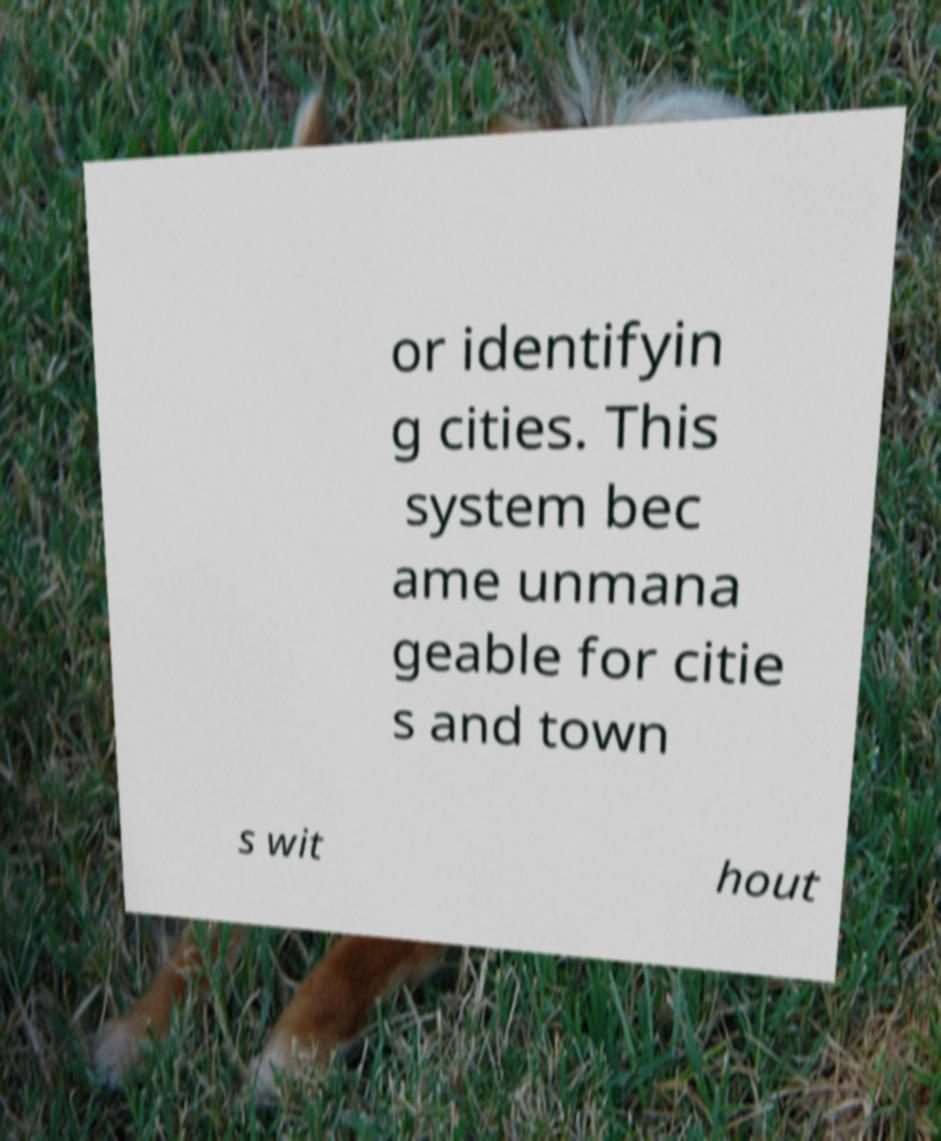For documentation purposes, I need the text within this image transcribed. Could you provide that? or identifyin g cities. This system bec ame unmana geable for citie s and town s wit hout 